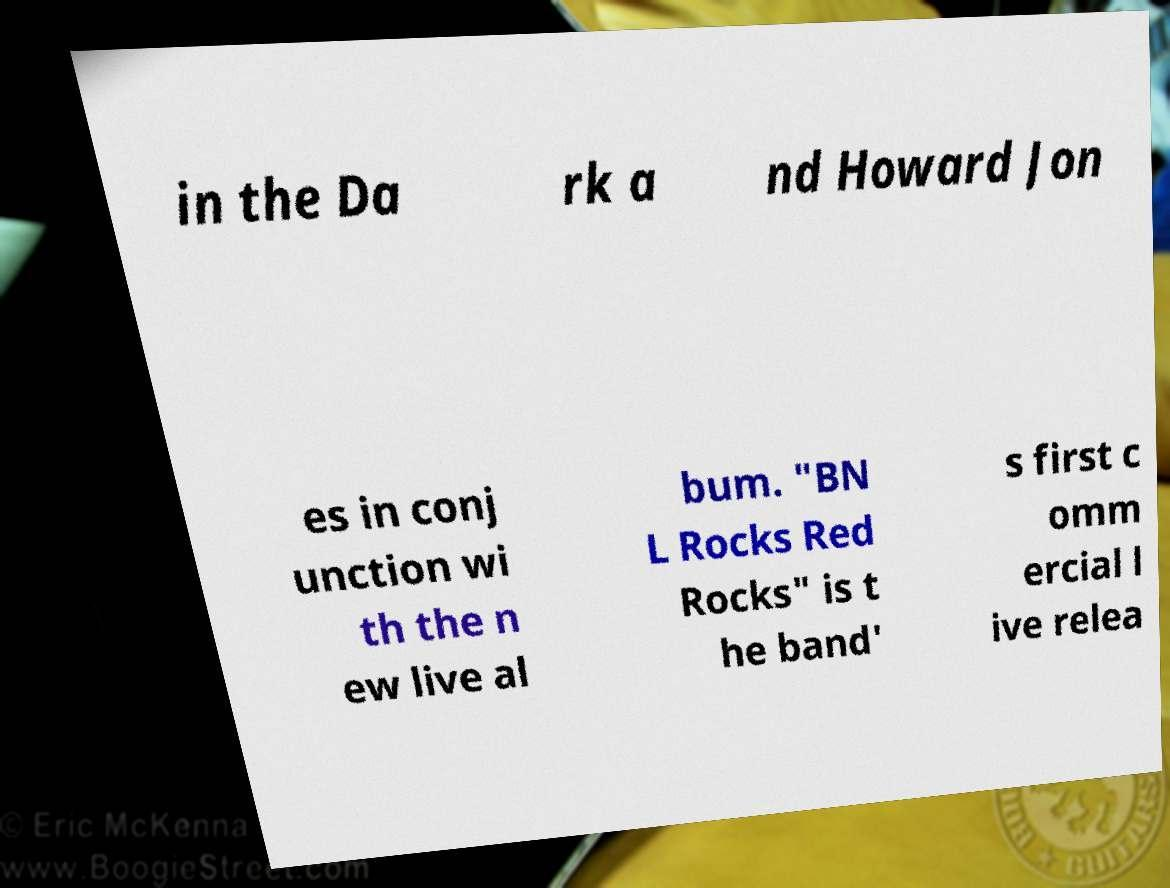What messages or text are displayed in this image? I need them in a readable, typed format. in the Da rk a nd Howard Jon es in conj unction wi th the n ew live al bum. "BN L Rocks Red Rocks" is t he band' s first c omm ercial l ive relea 